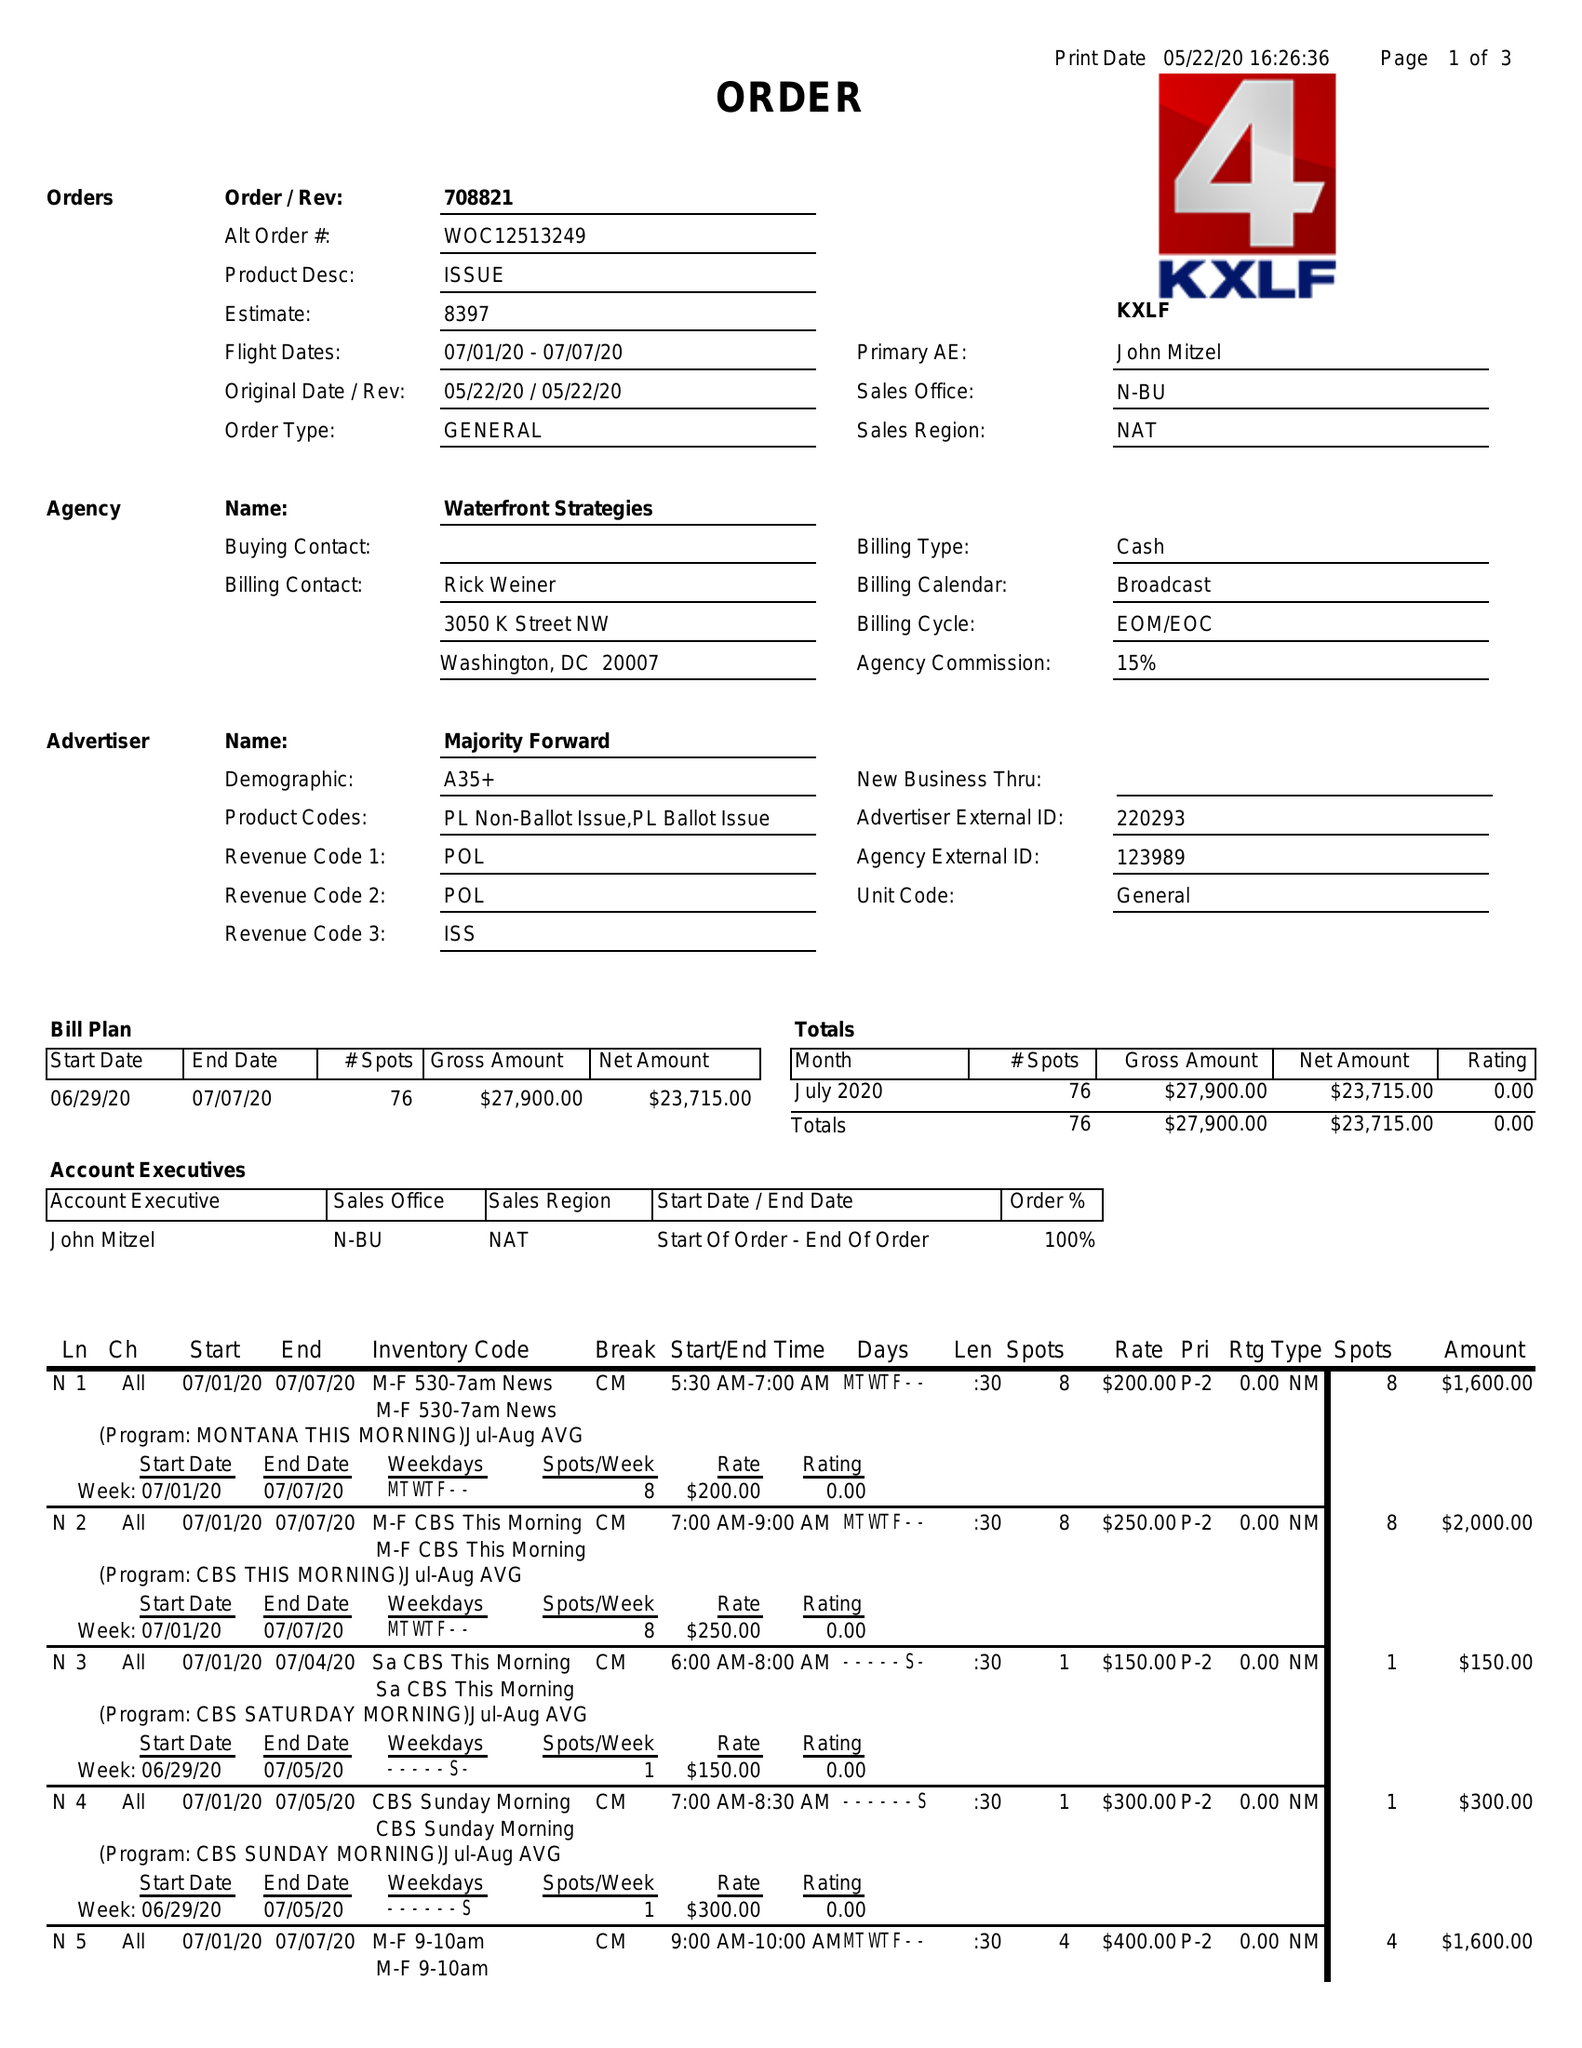What is the value for the flight_to?
Answer the question using a single word or phrase. 07/07/20 